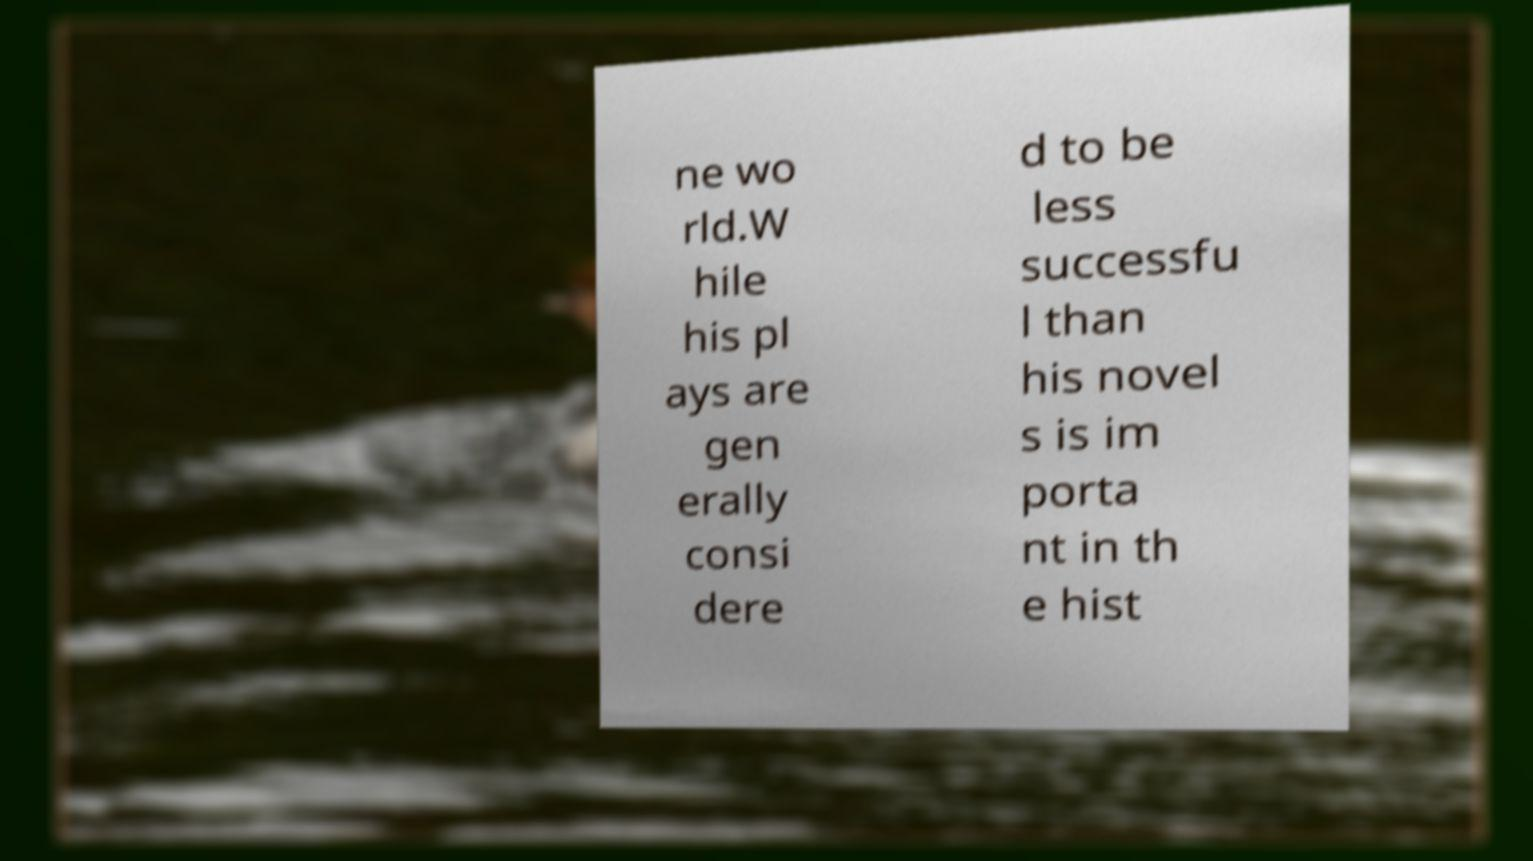Could you extract and type out the text from this image? ne wo rld.W hile his pl ays are gen erally consi dere d to be less successfu l than his novel s is im porta nt in th e hist 